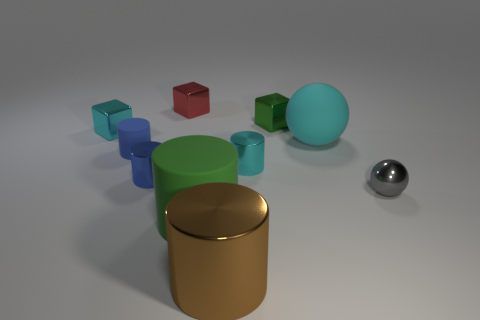Subtract all tiny blue rubber cylinders. How many cylinders are left? 4 Subtract 4 cylinders. How many cylinders are left? 1 Subtract all green blocks. How many blocks are left? 2 Subtract all gray blocks. How many cyan cylinders are left? 1 Add 6 cyan metal cylinders. How many cyan metal cylinders are left? 7 Add 2 tiny red spheres. How many tiny red spheres exist? 2 Subtract 0 gray cylinders. How many objects are left? 10 Subtract all balls. How many objects are left? 8 Subtract all cyan cubes. Subtract all brown cylinders. How many cubes are left? 2 Subtract all tiny green metal cubes. Subtract all cubes. How many objects are left? 6 